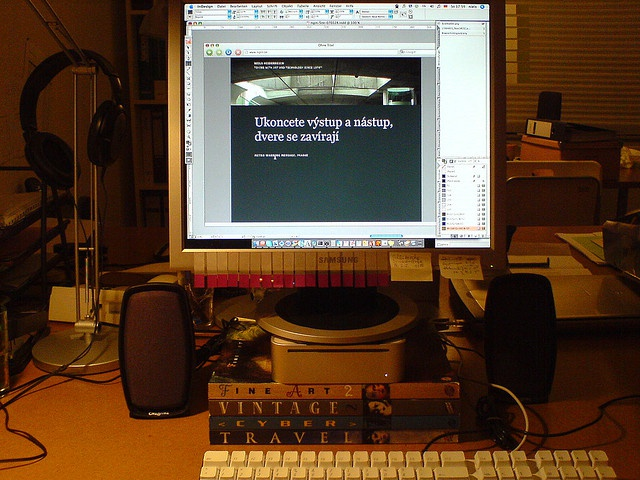Describe the objects in this image and their specific colors. I can see tv in maroon, white, black, darkgray, and purple tones, keyboard in maroon, olive, and orange tones, book in maroon, black, and brown tones, book in maroon, black, and brown tones, and chair in black and maroon tones in this image. 